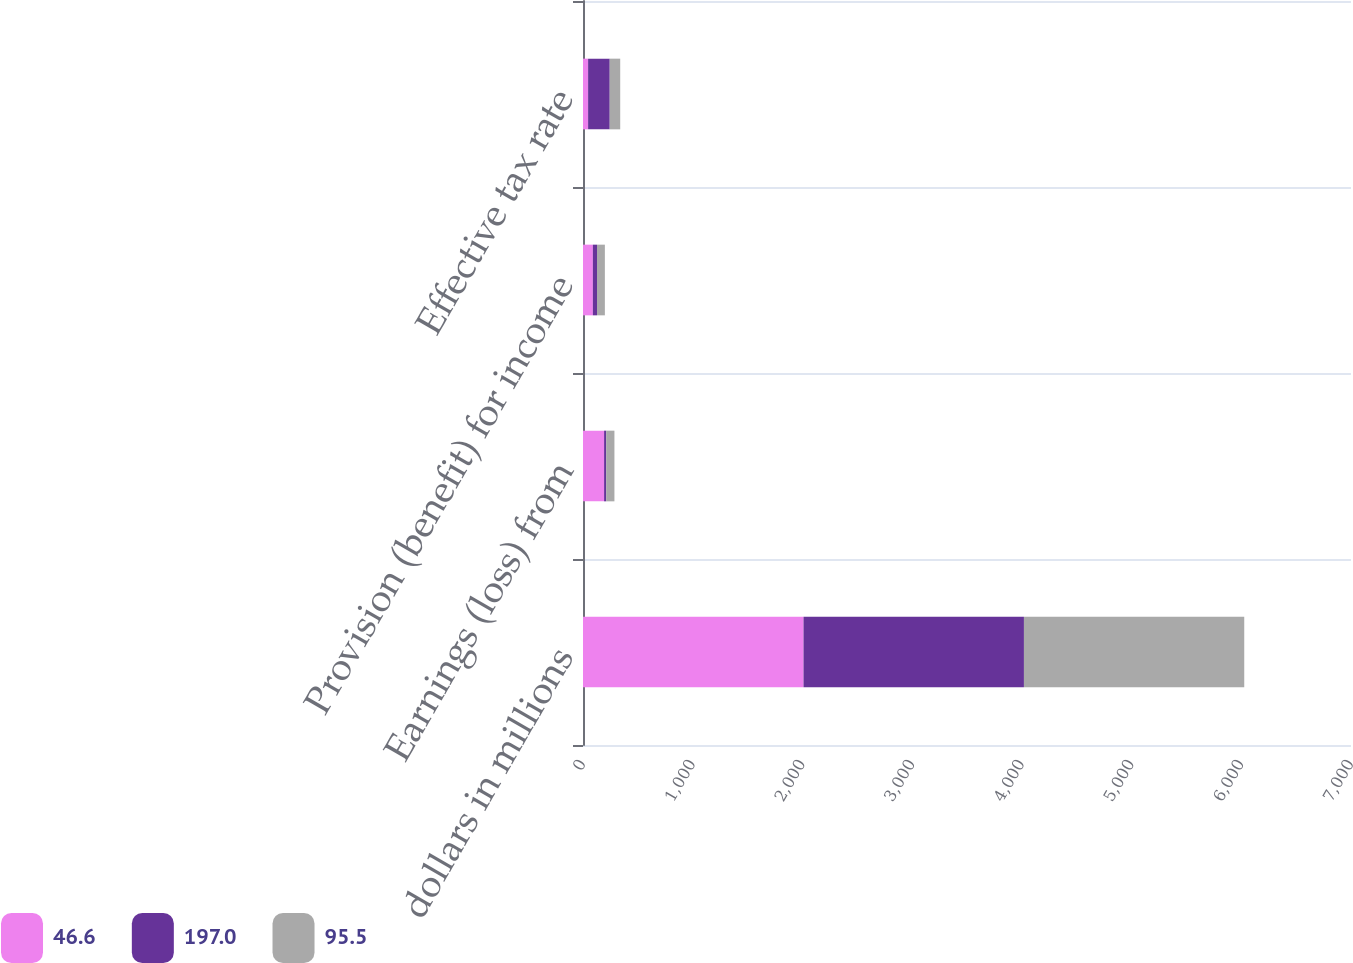<chart> <loc_0><loc_0><loc_500><loc_500><stacked_bar_chart><ecel><fcel>dollars in millions<fcel>Earnings (loss) from<fcel>Provision (benefit) for income<fcel>Effective tax rate<nl><fcel>46.6<fcel>2010<fcel>192.2<fcel>89.7<fcel>46.6<nl><fcel>197<fcel>2009<fcel>19.2<fcel>37.9<fcel>197<nl><fcel>95.5<fcel>2008<fcel>75.1<fcel>71.7<fcel>95.5<nl></chart> 